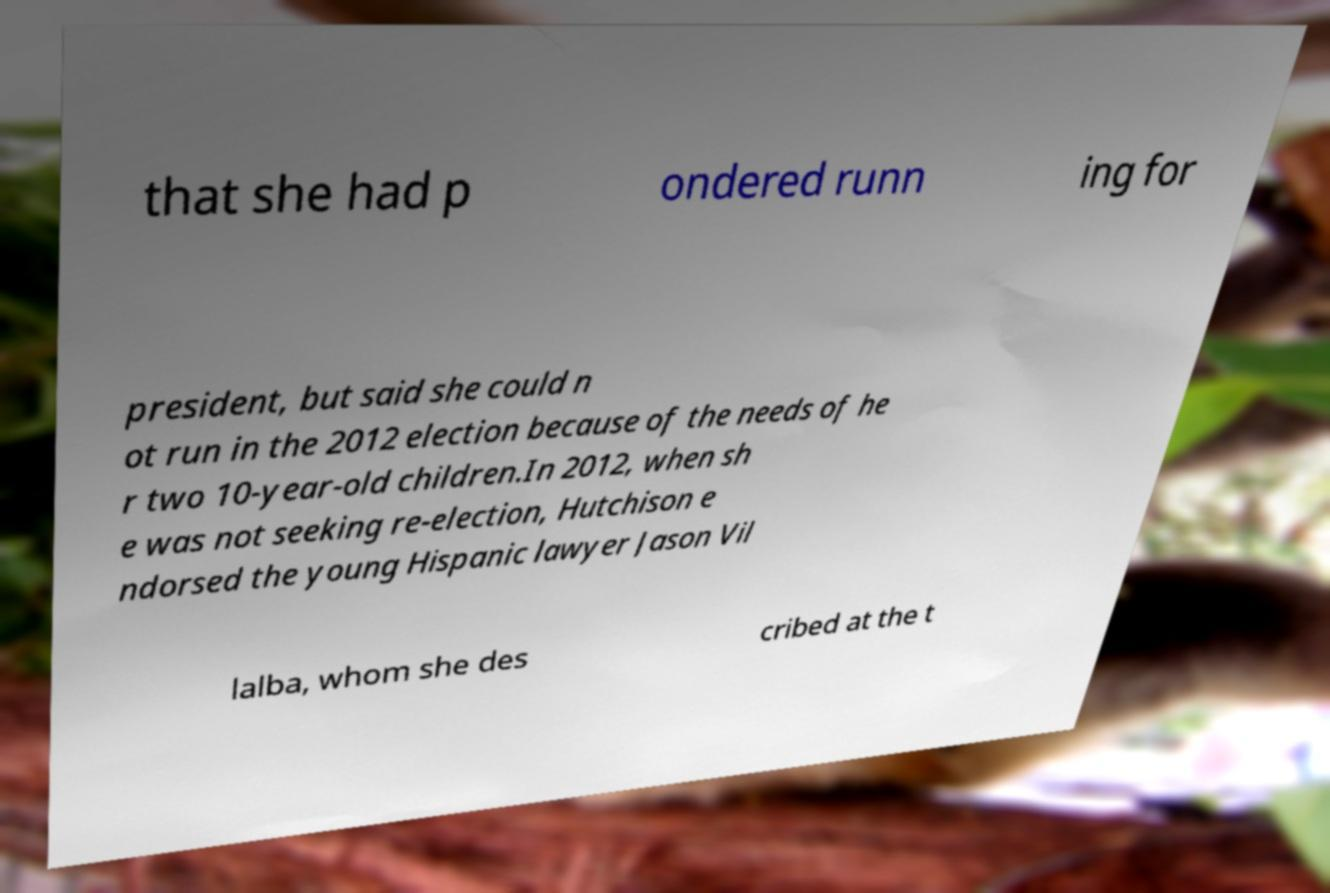Could you extract and type out the text from this image? that she had p ondered runn ing for president, but said she could n ot run in the 2012 election because of the needs of he r two 10-year-old children.In 2012, when sh e was not seeking re-election, Hutchison e ndorsed the young Hispanic lawyer Jason Vil lalba, whom she des cribed at the t 